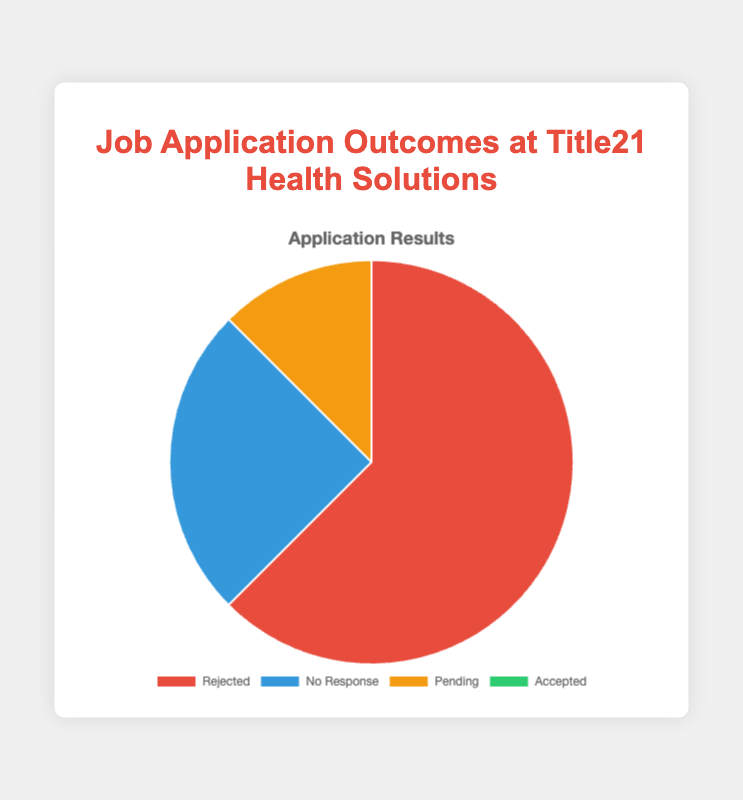Which outcome category has the highest number of applications for Title21 Health Solutions? Looking at the pie chart, the largest section is for the 'Rejected' category.
Answer: Rejected What is the total number of applications for Title21 Health Solutions excluding 'Accepted'? Add the counts for 'Rejected', 'No Response', and 'Pending': 5 + 2 + 1 = 8.
Answer: 8 How many more applications were 'Rejected' compared to 'Pending' at Title21 Health Solutions? The 'Rejected' category has 5 applications, while 'Pending' has 1. The difference is 5 - 1 = 4.
Answer: 4 What percentage of the total applications for Title21 Health Solutions were 'No Response'? The total number of applications is 5 + 2 + 1 + 0 = 8. The 'No Response' category has 2 applications, which is (2/8) * 100 = 25%.
Answer: 25% How does the number of 'Rejected' applications compare to the sum of 'Pending' and 'No Response' at Title21 Health Solutions? The number of 'Rejected' applications is 5. The sum of 'Pending' and 'No Response' is 1 + 2 = 3. Since 5 is greater than 3, 'Rejected' applications are more.
Answer: Rejected is more Which color represents the 'No Response' category for Title21 Health Solutions? The 'No Response' category is represented by the blue section of the pie chart.
Answer: Blue If you combine 'Pending' and 'Accepted' applications, how many total applications would that be at Title21 Health Solutions? The 'Pending' applications count is 1 and 'Accepted' is 0. Adding them together gives 1 + 0 = 1.
Answer: 1 What proportion of the 'Pending' applications is there compared to the total 'Rejected' applications for Title21 Health Solutions? The 'Pending' applications are 1, and the 'Rejected' applications are 5. The proportion is 1/5 = 0.2 or 20%.
Answer: 20% What is the difference between the total number of 'No Response' and 'Pending' applications for Title21 Health Solutions? The 'No Response' applications are 2, and 'Pending' applications are 1. The difference is 2 - 1 = 1.
Answer: 1 How many times more 'Rejected' applications are there compared to 'Accepted' at Title21 Health Solutions? The 'Rejected' category has 5 applications, while 'Accepted' has 0. Since there are no accepted applications, the ratio is 5/0, indicating no accepted applications.
Answer: No accepted applications 